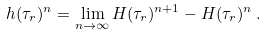<formula> <loc_0><loc_0><loc_500><loc_500>h ( \tau _ { r } ) ^ { n } = \lim _ { n \to \infty } H ( \tau _ { r } ) ^ { n + 1 } - H ( \tau _ { r } ) ^ { n } \, .</formula> 